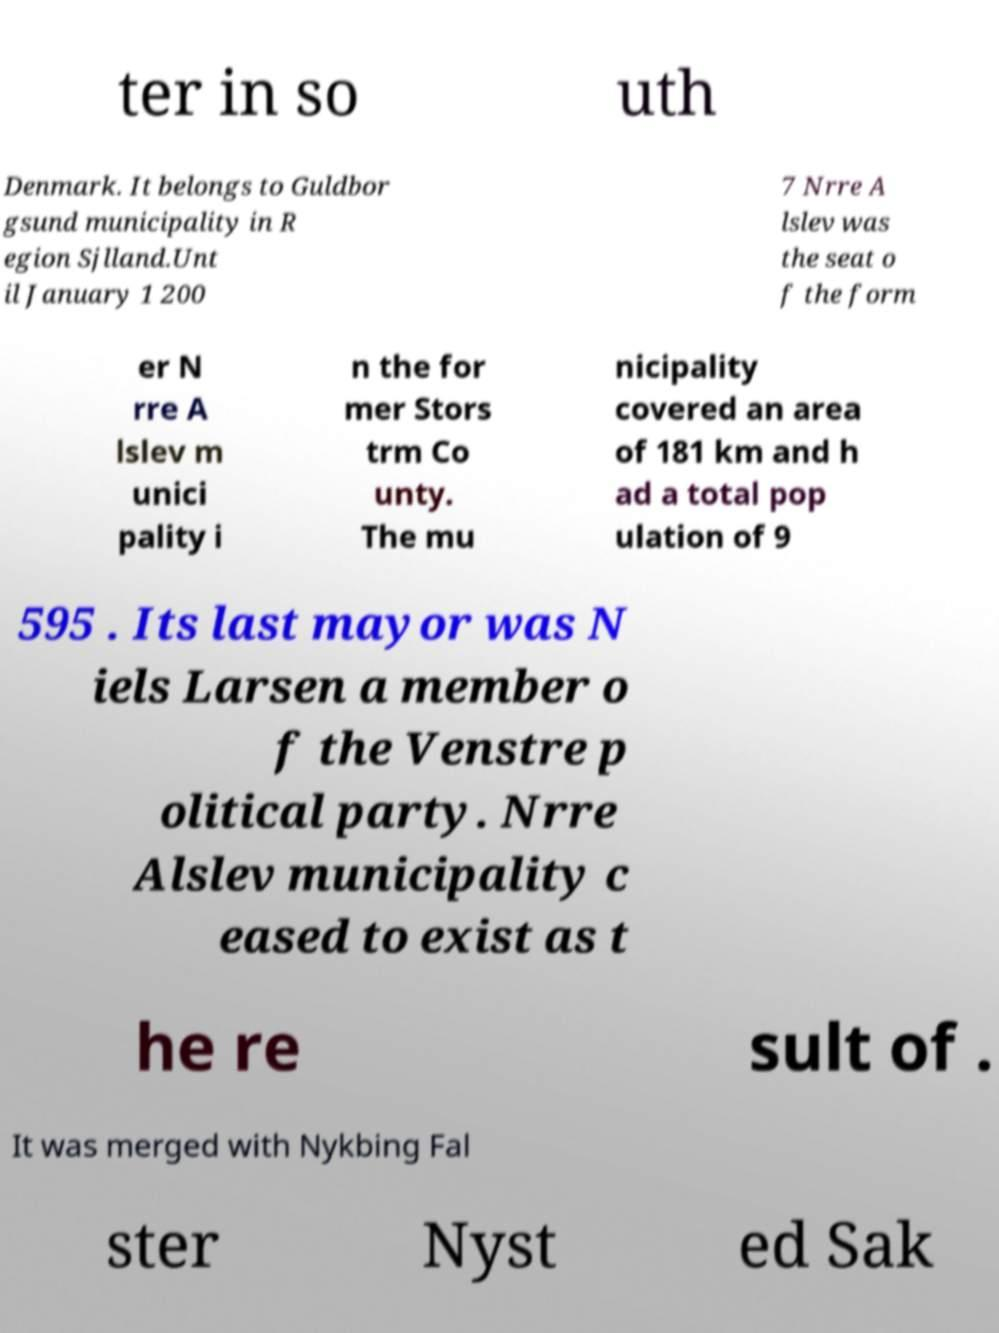Could you extract and type out the text from this image? ter in so uth Denmark. It belongs to Guldbor gsund municipality in R egion Sjlland.Unt il January 1 200 7 Nrre A lslev was the seat o f the form er N rre A lslev m unici pality i n the for mer Stors trm Co unty. The mu nicipality covered an area of 181 km and h ad a total pop ulation of 9 595 . Its last mayor was N iels Larsen a member o f the Venstre p olitical party. Nrre Alslev municipality c eased to exist as t he re sult of . It was merged with Nykbing Fal ster Nyst ed Sak 